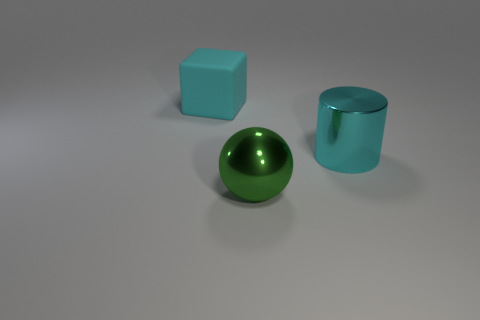Are there any other things that are the same material as the cube?
Your response must be concise. No. Do the cube and the metallic object that is in front of the cyan metallic thing have the same color?
Your response must be concise. No. There is a big rubber thing; does it have the same shape as the cyan object on the right side of the rubber block?
Your answer should be very brief. No. What number of big rubber cubes are in front of the large metal object that is to the right of the big metallic sphere?
Give a very brief answer. 0. What number of blue things are either big things or big metal balls?
Offer a terse response. 0. Is there anything else of the same color as the cube?
Your answer should be compact. Yes. There is a large shiny object to the right of the big object that is in front of the cyan metal object; what is its color?
Offer a terse response. Cyan. Are there fewer rubber cubes that are behind the cyan rubber block than big metallic spheres behind the large cyan cylinder?
Keep it short and to the point. No. What material is the other large object that is the same color as the matte object?
Your answer should be compact. Metal. What number of objects are big cyan objects that are behind the cylinder or big cylinders?
Offer a very short reply. 2. 